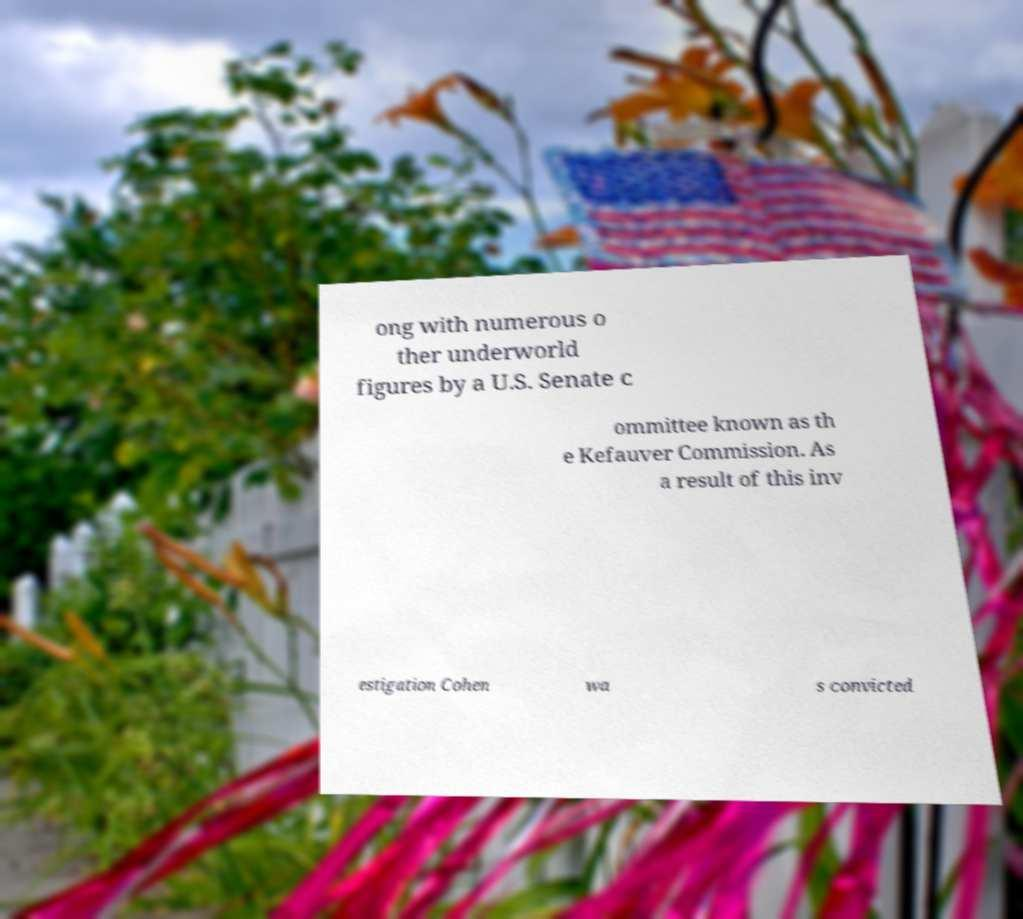For documentation purposes, I need the text within this image transcribed. Could you provide that? ong with numerous o ther underworld figures by a U.S. Senate c ommittee known as th e Kefauver Commission. As a result of this inv estigation Cohen wa s convicted 